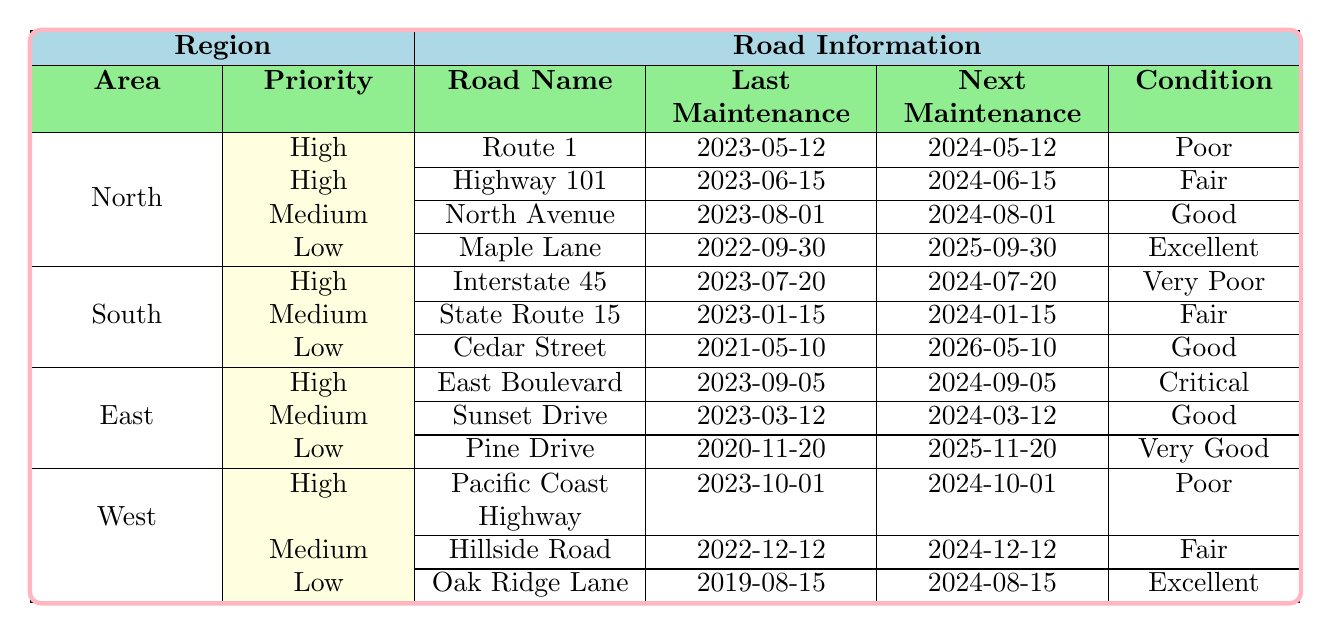What is the condition of Route 1 in the North region? The table indicates that Route 1 has a condition marked as "Poor."
Answer: Poor When is the next scheduled maintenance for Highway 101? The next scheduled maintenance for Highway 101 is set for 2024-06-15.
Answer: 2024-06-15 How many roads in the South region have a high priority level? There is 1 road listed in the South region with a high priority level, which is Interstate 45.
Answer: 1 Is there any road in the West region that has been maintained more recently than any in the North region? Yes, the Pacific Coast Highway in the West region was last maintained on 2023-10-01, which is after the last maintenance dates of both Route 1 and Highway 101 in the North region.
Answer: Yes What is the average condition rating of roads with high priority across all regions? The high priority roads have varying conditions: Poor (Route 1), Fair (Highway 101), Very Poor (Interstate 45), Critical (East Boulevard), and Poor (Pacific Coast Highway). The average condition rating is difficult to quantify numerically but can be summarized as generally unsafe, primarily poor.
Answer: Generally unsafe Which region has the road with the worst condition? East Boulevard in the East region is listed as "Critical," which is currently viewed as the worst condition among all roads.
Answer: East What is the earliest next scheduled maintenance date among all roads listed in the table? The earliest next scheduled maintenance date is for Cedar Street in the South region on 2026-05-10, which is the latest date among all due to its current "Good" condition and previous maintenance date of 2021-05-10.
Answer: 2026-05-10 How many roads in the East region are rated as “Good”? There are 2 roads in the East region rated as "Good" - Sunset Drive and Pine Drive.
Answer: 2 What is the difference in the number of high-priority roads between the North and South regions? The North region has 2 high-priority roads while the South region has 1, resulting in a difference of 1 road favoring the North region.
Answer: 1 Is there any road in the Low priority section that requires immediate action? No, all roads in the Low priority section listed have conditions classified as either Excellent or Very Good, indicating they do not require immediate action.
Answer: No Which region has the highest number of roads listed overall? The North region has 4 roads listed, which is the highest compared to other regions having 3 roads each.
Answer: North 